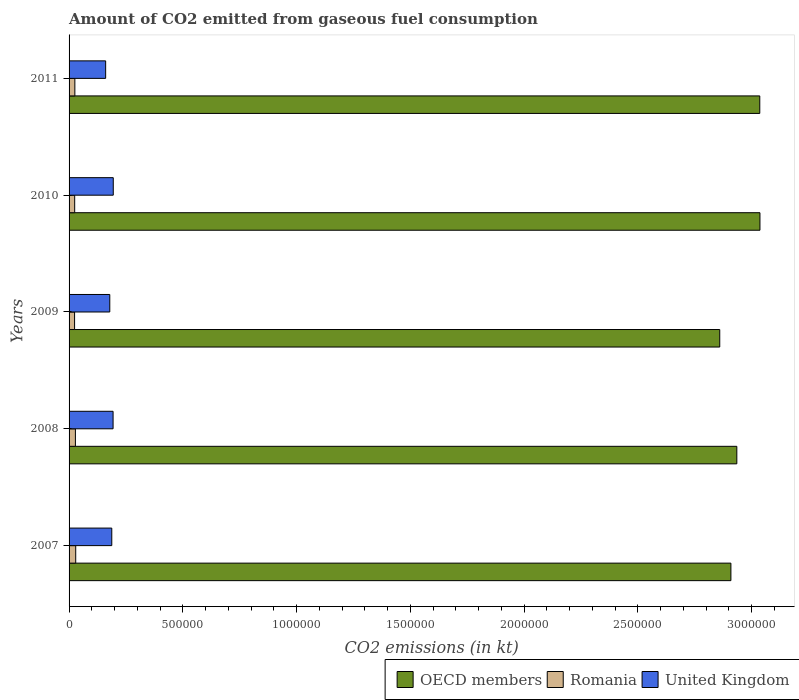How many groups of bars are there?
Ensure brevity in your answer.  5. How many bars are there on the 4th tick from the bottom?
Offer a terse response. 3. What is the amount of CO2 emitted in OECD members in 2009?
Provide a succinct answer. 2.86e+06. Across all years, what is the maximum amount of CO2 emitted in Romania?
Give a very brief answer. 2.92e+04. Across all years, what is the minimum amount of CO2 emitted in United Kingdom?
Provide a short and direct response. 1.61e+05. In which year was the amount of CO2 emitted in United Kingdom minimum?
Provide a short and direct response. 2011. What is the total amount of CO2 emitted in United Kingdom in the graph?
Give a very brief answer. 9.15e+05. What is the difference between the amount of CO2 emitted in OECD members in 2009 and that in 2011?
Your answer should be very brief. -1.76e+05. What is the difference between the amount of CO2 emitted in OECD members in 2009 and the amount of CO2 emitted in Romania in 2008?
Offer a terse response. 2.83e+06. What is the average amount of CO2 emitted in OECD members per year?
Offer a terse response. 2.96e+06. In the year 2010, what is the difference between the amount of CO2 emitted in United Kingdom and amount of CO2 emitted in Romania?
Ensure brevity in your answer.  1.70e+05. In how many years, is the amount of CO2 emitted in United Kingdom greater than 600000 kt?
Give a very brief answer. 0. What is the ratio of the amount of CO2 emitted in Romania in 2009 to that in 2011?
Provide a succinct answer. 0.95. Is the amount of CO2 emitted in United Kingdom in 2008 less than that in 2010?
Give a very brief answer. Yes. Is the difference between the amount of CO2 emitted in United Kingdom in 2007 and 2011 greater than the difference between the amount of CO2 emitted in Romania in 2007 and 2011?
Make the answer very short. Yes. What is the difference between the highest and the second highest amount of CO2 emitted in OECD members?
Give a very brief answer. 759.37. What is the difference between the highest and the lowest amount of CO2 emitted in OECD members?
Provide a succinct answer. 1.77e+05. Is it the case that in every year, the sum of the amount of CO2 emitted in OECD members and amount of CO2 emitted in United Kingdom is greater than the amount of CO2 emitted in Romania?
Offer a terse response. Yes. Are the values on the major ticks of X-axis written in scientific E-notation?
Your answer should be compact. No. Does the graph contain any zero values?
Provide a short and direct response. No. Where does the legend appear in the graph?
Ensure brevity in your answer.  Bottom right. How many legend labels are there?
Offer a terse response. 3. How are the legend labels stacked?
Your response must be concise. Horizontal. What is the title of the graph?
Provide a short and direct response. Amount of CO2 emitted from gaseous fuel consumption. Does "Israel" appear as one of the legend labels in the graph?
Ensure brevity in your answer.  No. What is the label or title of the X-axis?
Your response must be concise. CO2 emissions (in kt). What is the CO2 emissions (in kt) of OECD members in 2007?
Keep it short and to the point. 2.91e+06. What is the CO2 emissions (in kt) of Romania in 2007?
Ensure brevity in your answer.  2.92e+04. What is the CO2 emissions (in kt) in United Kingdom in 2007?
Ensure brevity in your answer.  1.88e+05. What is the CO2 emissions (in kt) in OECD members in 2008?
Provide a short and direct response. 2.94e+06. What is the CO2 emissions (in kt) of Romania in 2008?
Your response must be concise. 2.79e+04. What is the CO2 emissions (in kt) of United Kingdom in 2008?
Keep it short and to the point. 1.93e+05. What is the CO2 emissions (in kt) of OECD members in 2009?
Keep it short and to the point. 2.86e+06. What is the CO2 emissions (in kt) in Romania in 2009?
Offer a terse response. 2.42e+04. What is the CO2 emissions (in kt) of United Kingdom in 2009?
Offer a terse response. 1.79e+05. What is the CO2 emissions (in kt) in OECD members in 2010?
Ensure brevity in your answer.  3.04e+06. What is the CO2 emissions (in kt) in Romania in 2010?
Offer a terse response. 2.47e+04. What is the CO2 emissions (in kt) in United Kingdom in 2010?
Provide a succinct answer. 1.94e+05. What is the CO2 emissions (in kt) in OECD members in 2011?
Your answer should be compact. 3.04e+06. What is the CO2 emissions (in kt) of Romania in 2011?
Offer a very short reply. 2.54e+04. What is the CO2 emissions (in kt) in United Kingdom in 2011?
Offer a very short reply. 1.61e+05. Across all years, what is the maximum CO2 emissions (in kt) of OECD members?
Your answer should be very brief. 3.04e+06. Across all years, what is the maximum CO2 emissions (in kt) of Romania?
Your response must be concise. 2.92e+04. Across all years, what is the maximum CO2 emissions (in kt) in United Kingdom?
Give a very brief answer. 1.94e+05. Across all years, what is the minimum CO2 emissions (in kt) in OECD members?
Provide a succinct answer. 2.86e+06. Across all years, what is the minimum CO2 emissions (in kt) of Romania?
Offer a terse response. 2.42e+04. Across all years, what is the minimum CO2 emissions (in kt) in United Kingdom?
Ensure brevity in your answer.  1.61e+05. What is the total CO2 emissions (in kt) of OECD members in the graph?
Ensure brevity in your answer.  1.48e+07. What is the total CO2 emissions (in kt) of Romania in the graph?
Offer a very short reply. 1.31e+05. What is the total CO2 emissions (in kt) in United Kingdom in the graph?
Offer a terse response. 9.15e+05. What is the difference between the CO2 emissions (in kt) of OECD members in 2007 and that in 2008?
Ensure brevity in your answer.  -2.60e+04. What is the difference between the CO2 emissions (in kt) of Romania in 2007 and that in 2008?
Your answer should be very brief. 1378.79. What is the difference between the CO2 emissions (in kt) in United Kingdom in 2007 and that in 2008?
Your answer should be compact. -5731.52. What is the difference between the CO2 emissions (in kt) in OECD members in 2007 and that in 2009?
Your response must be concise. 4.91e+04. What is the difference between the CO2 emissions (in kt) in Romania in 2007 and that in 2009?
Offer a very short reply. 4998.12. What is the difference between the CO2 emissions (in kt) in United Kingdom in 2007 and that in 2009?
Offer a terse response. 8804.47. What is the difference between the CO2 emissions (in kt) of OECD members in 2007 and that in 2010?
Ensure brevity in your answer.  -1.28e+05. What is the difference between the CO2 emissions (in kt) in Romania in 2007 and that in 2010?
Give a very brief answer. 4521.41. What is the difference between the CO2 emissions (in kt) in United Kingdom in 2007 and that in 2010?
Your answer should be compact. -6527.26. What is the difference between the CO2 emissions (in kt) in OECD members in 2007 and that in 2011?
Offer a terse response. -1.27e+05. What is the difference between the CO2 emissions (in kt) in Romania in 2007 and that in 2011?
Give a very brief answer. 3795.34. What is the difference between the CO2 emissions (in kt) of United Kingdom in 2007 and that in 2011?
Provide a short and direct response. 2.69e+04. What is the difference between the CO2 emissions (in kt) in OECD members in 2008 and that in 2009?
Offer a terse response. 7.51e+04. What is the difference between the CO2 emissions (in kt) of Romania in 2008 and that in 2009?
Your response must be concise. 3619.33. What is the difference between the CO2 emissions (in kt) of United Kingdom in 2008 and that in 2009?
Your answer should be compact. 1.45e+04. What is the difference between the CO2 emissions (in kt) of OECD members in 2008 and that in 2010?
Ensure brevity in your answer.  -1.02e+05. What is the difference between the CO2 emissions (in kt) of Romania in 2008 and that in 2010?
Offer a terse response. 3142.62. What is the difference between the CO2 emissions (in kt) in United Kingdom in 2008 and that in 2010?
Make the answer very short. -795.74. What is the difference between the CO2 emissions (in kt) of OECD members in 2008 and that in 2011?
Keep it short and to the point. -1.01e+05. What is the difference between the CO2 emissions (in kt) of Romania in 2008 and that in 2011?
Give a very brief answer. 2416.55. What is the difference between the CO2 emissions (in kt) of United Kingdom in 2008 and that in 2011?
Make the answer very short. 3.27e+04. What is the difference between the CO2 emissions (in kt) of OECD members in 2009 and that in 2010?
Provide a succinct answer. -1.77e+05. What is the difference between the CO2 emissions (in kt) of Romania in 2009 and that in 2010?
Provide a succinct answer. -476.71. What is the difference between the CO2 emissions (in kt) of United Kingdom in 2009 and that in 2010?
Offer a terse response. -1.53e+04. What is the difference between the CO2 emissions (in kt) of OECD members in 2009 and that in 2011?
Provide a succinct answer. -1.76e+05. What is the difference between the CO2 emissions (in kt) of Romania in 2009 and that in 2011?
Offer a terse response. -1202.78. What is the difference between the CO2 emissions (in kt) in United Kingdom in 2009 and that in 2011?
Provide a succinct answer. 1.81e+04. What is the difference between the CO2 emissions (in kt) of OECD members in 2010 and that in 2011?
Keep it short and to the point. 759.37. What is the difference between the CO2 emissions (in kt) in Romania in 2010 and that in 2011?
Provide a short and direct response. -726.07. What is the difference between the CO2 emissions (in kt) of United Kingdom in 2010 and that in 2011?
Your answer should be very brief. 3.35e+04. What is the difference between the CO2 emissions (in kt) in OECD members in 2007 and the CO2 emissions (in kt) in Romania in 2008?
Make the answer very short. 2.88e+06. What is the difference between the CO2 emissions (in kt) of OECD members in 2007 and the CO2 emissions (in kt) of United Kingdom in 2008?
Provide a short and direct response. 2.72e+06. What is the difference between the CO2 emissions (in kt) of Romania in 2007 and the CO2 emissions (in kt) of United Kingdom in 2008?
Give a very brief answer. -1.64e+05. What is the difference between the CO2 emissions (in kt) of OECD members in 2007 and the CO2 emissions (in kt) of Romania in 2009?
Provide a succinct answer. 2.88e+06. What is the difference between the CO2 emissions (in kt) of OECD members in 2007 and the CO2 emissions (in kt) of United Kingdom in 2009?
Provide a succinct answer. 2.73e+06. What is the difference between the CO2 emissions (in kt) of Romania in 2007 and the CO2 emissions (in kt) of United Kingdom in 2009?
Make the answer very short. -1.50e+05. What is the difference between the CO2 emissions (in kt) of OECD members in 2007 and the CO2 emissions (in kt) of Romania in 2010?
Provide a succinct answer. 2.88e+06. What is the difference between the CO2 emissions (in kt) in OECD members in 2007 and the CO2 emissions (in kt) in United Kingdom in 2010?
Give a very brief answer. 2.71e+06. What is the difference between the CO2 emissions (in kt) in Romania in 2007 and the CO2 emissions (in kt) in United Kingdom in 2010?
Keep it short and to the point. -1.65e+05. What is the difference between the CO2 emissions (in kt) in OECD members in 2007 and the CO2 emissions (in kt) in Romania in 2011?
Keep it short and to the point. 2.88e+06. What is the difference between the CO2 emissions (in kt) of OECD members in 2007 and the CO2 emissions (in kt) of United Kingdom in 2011?
Ensure brevity in your answer.  2.75e+06. What is the difference between the CO2 emissions (in kt) of Romania in 2007 and the CO2 emissions (in kt) of United Kingdom in 2011?
Your answer should be very brief. -1.32e+05. What is the difference between the CO2 emissions (in kt) of OECD members in 2008 and the CO2 emissions (in kt) of Romania in 2009?
Your response must be concise. 2.91e+06. What is the difference between the CO2 emissions (in kt) of OECD members in 2008 and the CO2 emissions (in kt) of United Kingdom in 2009?
Your answer should be very brief. 2.76e+06. What is the difference between the CO2 emissions (in kt) in Romania in 2008 and the CO2 emissions (in kt) in United Kingdom in 2009?
Provide a succinct answer. -1.51e+05. What is the difference between the CO2 emissions (in kt) in OECD members in 2008 and the CO2 emissions (in kt) in Romania in 2010?
Your answer should be very brief. 2.91e+06. What is the difference between the CO2 emissions (in kt) in OECD members in 2008 and the CO2 emissions (in kt) in United Kingdom in 2010?
Offer a terse response. 2.74e+06. What is the difference between the CO2 emissions (in kt) in Romania in 2008 and the CO2 emissions (in kt) in United Kingdom in 2010?
Your answer should be very brief. -1.66e+05. What is the difference between the CO2 emissions (in kt) of OECD members in 2008 and the CO2 emissions (in kt) of Romania in 2011?
Ensure brevity in your answer.  2.91e+06. What is the difference between the CO2 emissions (in kt) of OECD members in 2008 and the CO2 emissions (in kt) of United Kingdom in 2011?
Provide a short and direct response. 2.77e+06. What is the difference between the CO2 emissions (in kt) of Romania in 2008 and the CO2 emissions (in kt) of United Kingdom in 2011?
Ensure brevity in your answer.  -1.33e+05. What is the difference between the CO2 emissions (in kt) of OECD members in 2009 and the CO2 emissions (in kt) of Romania in 2010?
Your answer should be compact. 2.84e+06. What is the difference between the CO2 emissions (in kt) of OECD members in 2009 and the CO2 emissions (in kt) of United Kingdom in 2010?
Ensure brevity in your answer.  2.67e+06. What is the difference between the CO2 emissions (in kt) in Romania in 2009 and the CO2 emissions (in kt) in United Kingdom in 2010?
Give a very brief answer. -1.70e+05. What is the difference between the CO2 emissions (in kt) of OECD members in 2009 and the CO2 emissions (in kt) of Romania in 2011?
Provide a short and direct response. 2.83e+06. What is the difference between the CO2 emissions (in kt) of OECD members in 2009 and the CO2 emissions (in kt) of United Kingdom in 2011?
Give a very brief answer. 2.70e+06. What is the difference between the CO2 emissions (in kt) in Romania in 2009 and the CO2 emissions (in kt) in United Kingdom in 2011?
Provide a succinct answer. -1.37e+05. What is the difference between the CO2 emissions (in kt) in OECD members in 2010 and the CO2 emissions (in kt) in Romania in 2011?
Provide a succinct answer. 3.01e+06. What is the difference between the CO2 emissions (in kt) of OECD members in 2010 and the CO2 emissions (in kt) of United Kingdom in 2011?
Offer a very short reply. 2.88e+06. What is the difference between the CO2 emissions (in kt) in Romania in 2010 and the CO2 emissions (in kt) in United Kingdom in 2011?
Make the answer very short. -1.36e+05. What is the average CO2 emissions (in kt) of OECD members per year?
Offer a terse response. 2.96e+06. What is the average CO2 emissions (in kt) in Romania per year?
Your answer should be compact. 2.63e+04. What is the average CO2 emissions (in kt) in United Kingdom per year?
Your answer should be very brief. 1.83e+05. In the year 2007, what is the difference between the CO2 emissions (in kt) of OECD members and CO2 emissions (in kt) of Romania?
Your response must be concise. 2.88e+06. In the year 2007, what is the difference between the CO2 emissions (in kt) of OECD members and CO2 emissions (in kt) of United Kingdom?
Provide a succinct answer. 2.72e+06. In the year 2007, what is the difference between the CO2 emissions (in kt) of Romania and CO2 emissions (in kt) of United Kingdom?
Ensure brevity in your answer.  -1.58e+05. In the year 2008, what is the difference between the CO2 emissions (in kt) in OECD members and CO2 emissions (in kt) in Romania?
Offer a terse response. 2.91e+06. In the year 2008, what is the difference between the CO2 emissions (in kt) in OECD members and CO2 emissions (in kt) in United Kingdom?
Your answer should be compact. 2.74e+06. In the year 2008, what is the difference between the CO2 emissions (in kt) of Romania and CO2 emissions (in kt) of United Kingdom?
Give a very brief answer. -1.66e+05. In the year 2009, what is the difference between the CO2 emissions (in kt) of OECD members and CO2 emissions (in kt) of Romania?
Your answer should be compact. 2.84e+06. In the year 2009, what is the difference between the CO2 emissions (in kt) in OECD members and CO2 emissions (in kt) in United Kingdom?
Your answer should be compact. 2.68e+06. In the year 2009, what is the difference between the CO2 emissions (in kt) in Romania and CO2 emissions (in kt) in United Kingdom?
Offer a terse response. -1.55e+05. In the year 2010, what is the difference between the CO2 emissions (in kt) of OECD members and CO2 emissions (in kt) of Romania?
Ensure brevity in your answer.  3.01e+06. In the year 2010, what is the difference between the CO2 emissions (in kt) of OECD members and CO2 emissions (in kt) of United Kingdom?
Offer a terse response. 2.84e+06. In the year 2010, what is the difference between the CO2 emissions (in kt) of Romania and CO2 emissions (in kt) of United Kingdom?
Your answer should be compact. -1.70e+05. In the year 2011, what is the difference between the CO2 emissions (in kt) of OECD members and CO2 emissions (in kt) of Romania?
Your answer should be compact. 3.01e+06. In the year 2011, what is the difference between the CO2 emissions (in kt) in OECD members and CO2 emissions (in kt) in United Kingdom?
Your answer should be compact. 2.88e+06. In the year 2011, what is the difference between the CO2 emissions (in kt) of Romania and CO2 emissions (in kt) of United Kingdom?
Offer a very short reply. -1.35e+05. What is the ratio of the CO2 emissions (in kt) in Romania in 2007 to that in 2008?
Give a very brief answer. 1.05. What is the ratio of the CO2 emissions (in kt) in United Kingdom in 2007 to that in 2008?
Your response must be concise. 0.97. What is the ratio of the CO2 emissions (in kt) in OECD members in 2007 to that in 2009?
Ensure brevity in your answer.  1.02. What is the ratio of the CO2 emissions (in kt) of Romania in 2007 to that in 2009?
Offer a terse response. 1.21. What is the ratio of the CO2 emissions (in kt) in United Kingdom in 2007 to that in 2009?
Keep it short and to the point. 1.05. What is the ratio of the CO2 emissions (in kt) of OECD members in 2007 to that in 2010?
Offer a terse response. 0.96. What is the ratio of the CO2 emissions (in kt) in Romania in 2007 to that in 2010?
Offer a very short reply. 1.18. What is the ratio of the CO2 emissions (in kt) of United Kingdom in 2007 to that in 2010?
Ensure brevity in your answer.  0.97. What is the ratio of the CO2 emissions (in kt) in OECD members in 2007 to that in 2011?
Give a very brief answer. 0.96. What is the ratio of the CO2 emissions (in kt) of Romania in 2007 to that in 2011?
Offer a terse response. 1.15. What is the ratio of the CO2 emissions (in kt) of United Kingdom in 2007 to that in 2011?
Your answer should be compact. 1.17. What is the ratio of the CO2 emissions (in kt) of OECD members in 2008 to that in 2009?
Your response must be concise. 1.03. What is the ratio of the CO2 emissions (in kt) of Romania in 2008 to that in 2009?
Make the answer very short. 1.15. What is the ratio of the CO2 emissions (in kt) of United Kingdom in 2008 to that in 2009?
Your answer should be very brief. 1.08. What is the ratio of the CO2 emissions (in kt) of OECD members in 2008 to that in 2010?
Your answer should be compact. 0.97. What is the ratio of the CO2 emissions (in kt) in Romania in 2008 to that in 2010?
Ensure brevity in your answer.  1.13. What is the ratio of the CO2 emissions (in kt) of United Kingdom in 2008 to that in 2010?
Your answer should be very brief. 1. What is the ratio of the CO2 emissions (in kt) of OECD members in 2008 to that in 2011?
Offer a very short reply. 0.97. What is the ratio of the CO2 emissions (in kt) in Romania in 2008 to that in 2011?
Offer a very short reply. 1.09. What is the ratio of the CO2 emissions (in kt) of United Kingdom in 2008 to that in 2011?
Give a very brief answer. 1.2. What is the ratio of the CO2 emissions (in kt) in OECD members in 2009 to that in 2010?
Offer a very short reply. 0.94. What is the ratio of the CO2 emissions (in kt) of Romania in 2009 to that in 2010?
Offer a very short reply. 0.98. What is the ratio of the CO2 emissions (in kt) in United Kingdom in 2009 to that in 2010?
Offer a terse response. 0.92. What is the ratio of the CO2 emissions (in kt) in OECD members in 2009 to that in 2011?
Ensure brevity in your answer.  0.94. What is the ratio of the CO2 emissions (in kt) of Romania in 2009 to that in 2011?
Keep it short and to the point. 0.95. What is the ratio of the CO2 emissions (in kt) of United Kingdom in 2009 to that in 2011?
Your answer should be compact. 1.11. What is the ratio of the CO2 emissions (in kt) in OECD members in 2010 to that in 2011?
Your answer should be compact. 1. What is the ratio of the CO2 emissions (in kt) of Romania in 2010 to that in 2011?
Keep it short and to the point. 0.97. What is the ratio of the CO2 emissions (in kt) of United Kingdom in 2010 to that in 2011?
Your answer should be compact. 1.21. What is the difference between the highest and the second highest CO2 emissions (in kt) in OECD members?
Provide a succinct answer. 759.37. What is the difference between the highest and the second highest CO2 emissions (in kt) of Romania?
Offer a terse response. 1378.79. What is the difference between the highest and the second highest CO2 emissions (in kt) in United Kingdom?
Your answer should be very brief. 795.74. What is the difference between the highest and the lowest CO2 emissions (in kt) of OECD members?
Your response must be concise. 1.77e+05. What is the difference between the highest and the lowest CO2 emissions (in kt) in Romania?
Offer a terse response. 4998.12. What is the difference between the highest and the lowest CO2 emissions (in kt) of United Kingdom?
Give a very brief answer. 3.35e+04. 